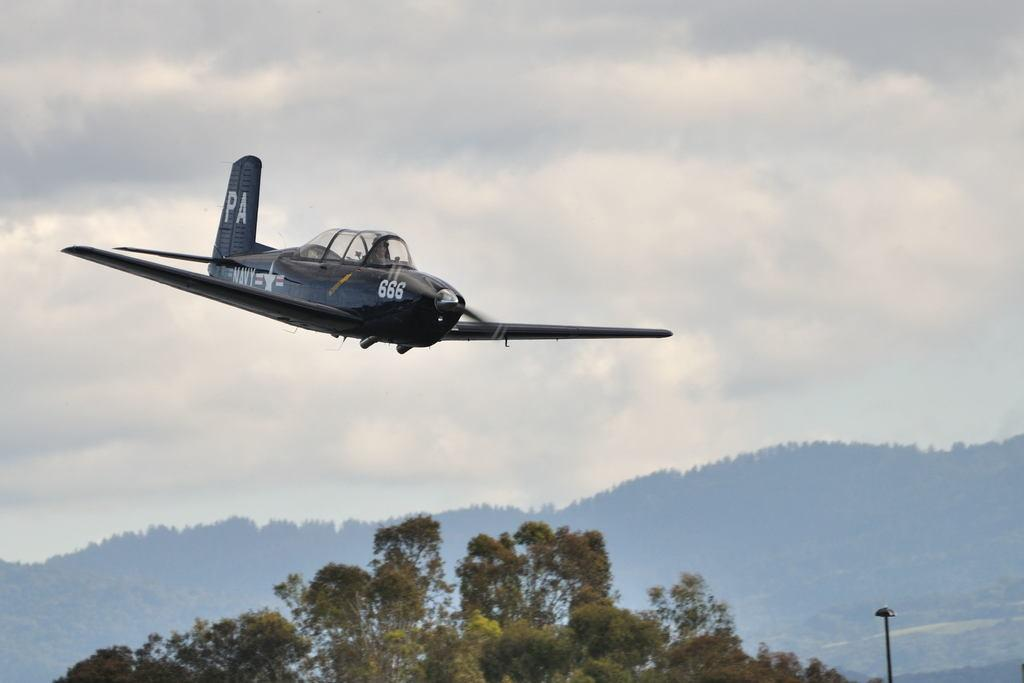<image>
Create a compact narrative representing the image presented. a plane is coming down with the numbers 666 on ity 